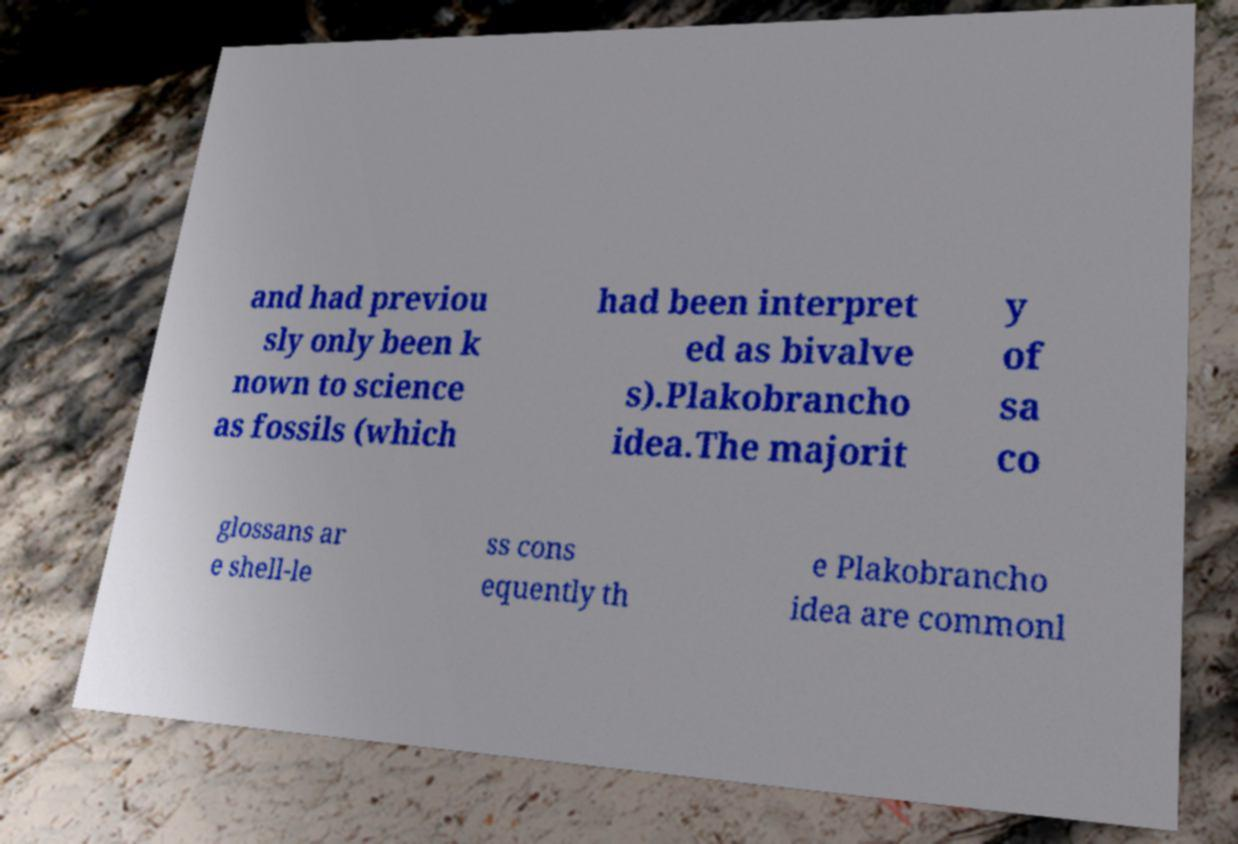Can you accurately transcribe the text from the provided image for me? and had previou sly only been k nown to science as fossils (which had been interpret ed as bivalve s).Plakobrancho idea.The majorit y of sa co glossans ar e shell-le ss cons equently th e Plakobrancho idea are commonl 